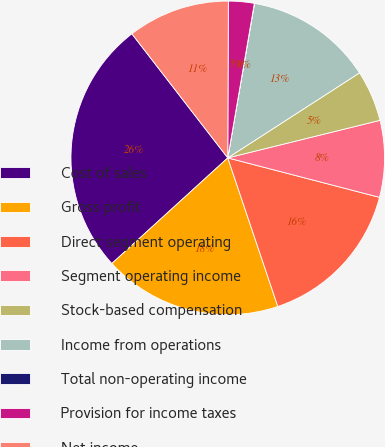Convert chart. <chart><loc_0><loc_0><loc_500><loc_500><pie_chart><fcel>Cost of sales<fcel>Gross profit<fcel>Direct segment operating<fcel>Segment operating income<fcel>Stock-based compensation<fcel>Income from operations<fcel>Total non-operating income<fcel>Provision for income taxes<fcel>Net income<nl><fcel>26.29%<fcel>18.41%<fcel>15.78%<fcel>7.9%<fcel>5.27%<fcel>13.15%<fcel>0.02%<fcel>2.65%<fcel>10.53%<nl></chart> 